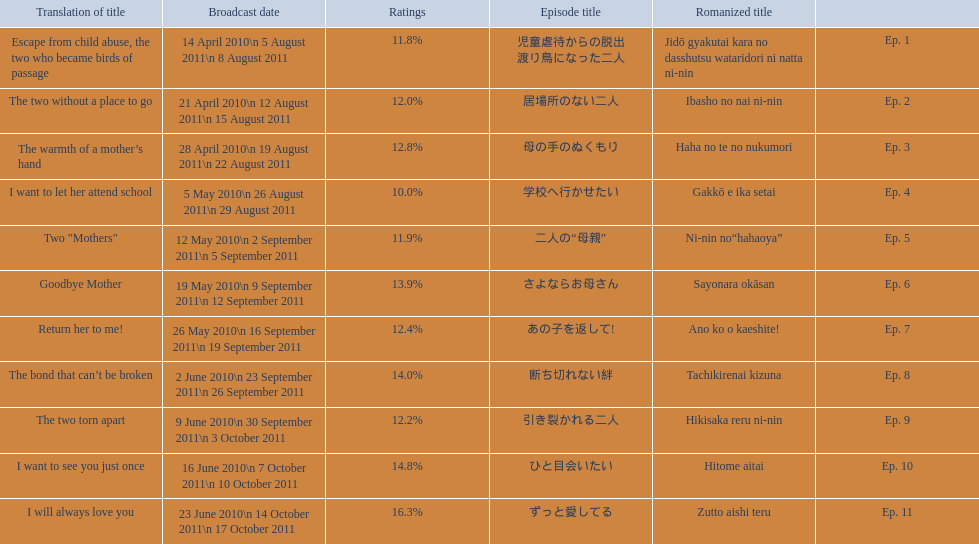How many episodes are listed? 11. 